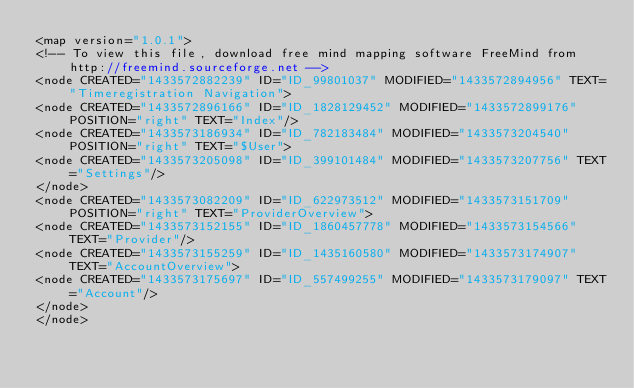Convert code to text. <code><loc_0><loc_0><loc_500><loc_500><_ObjectiveC_><map version="1.0.1">
<!-- To view this file, download free mind mapping software FreeMind from http://freemind.sourceforge.net -->
<node CREATED="1433572882239" ID="ID_99801037" MODIFIED="1433572894956" TEXT="Timeregistration Navigation">
<node CREATED="1433572896166" ID="ID_1828129452" MODIFIED="1433572899176" POSITION="right" TEXT="Index"/>
<node CREATED="1433573186934" ID="ID_782183484" MODIFIED="1433573204540" POSITION="right" TEXT="$User">
<node CREATED="1433573205098" ID="ID_399101484" MODIFIED="1433573207756" TEXT="Settings"/>
</node>
<node CREATED="1433573082209" ID="ID_622973512" MODIFIED="1433573151709" POSITION="right" TEXT="ProviderOverview">
<node CREATED="1433573152155" ID="ID_1860457778" MODIFIED="1433573154566" TEXT="Provider"/>
<node CREATED="1433573155259" ID="ID_1435160580" MODIFIED="1433573174907" TEXT="AccountOverview">
<node CREATED="1433573175697" ID="ID_557499255" MODIFIED="1433573179097" TEXT="Account"/>
</node>
</node></code> 